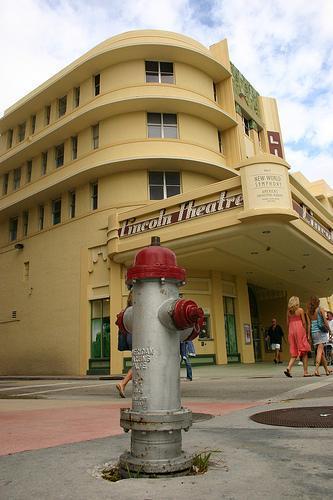How many fire hydrants are there?
Give a very brief answer. 1. 